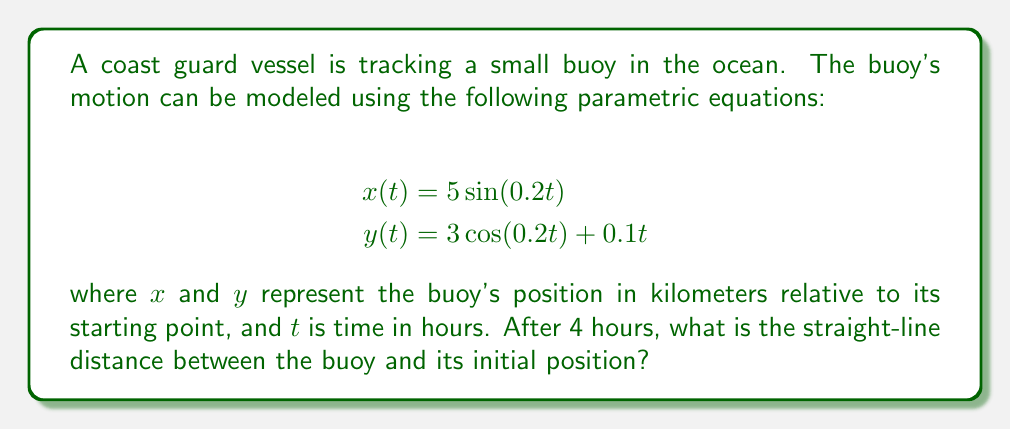What is the answer to this math problem? To solve this problem, we'll follow these steps:

1) First, we need to find the position of the buoy after 4 hours. We do this by plugging $t=4$ into our parametric equations:

   $$x(4) = 5 \sin(0.2 \cdot 4) = 5 \sin(0.8) \approx 3.6018 \text{ km}$$
   $$y(4) = 3 \cos(0.2 \cdot 4) + 0.1 \cdot 4 = 3 \cos(0.8) + 0.4 \approx 2.5860 \text{ km}$$

2) Now that we have the coordinates $(x,y)$ of the buoy after 4 hours, we can calculate the straight-line distance from the origin (0,0) using the distance formula:

   $$d = \sqrt{(x-0)^2 + (y-0)^2} = \sqrt{x^2 + y^2}$$

3) Plugging in our values:

   $$d = \sqrt{(3.6018)^2 + (2.5860)^2}$$

4) Calculating:

   $$d = \sqrt{12.9730 + 6.6874} = \sqrt{19.6604} \approx 4.4339 \text{ km}$$

Therefore, after 4 hours, the buoy is approximately 4.4339 kilometers from its starting point.
Answer: $4.4339 \text{ km}$ (rounded to 4 decimal places) 